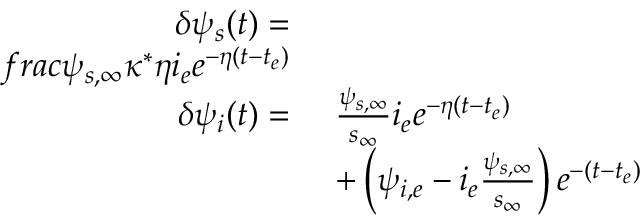<formula> <loc_0><loc_0><loc_500><loc_500>\begin{array} { r l } { \delta \psi _ { s } ( t ) = } \\ { f r a c { \psi _ { s , \infty } \kappa ^ { * } } { \eta } i _ { e } e ^ { - \eta ( t - t _ { e } ) } } \\ { \delta \psi _ { i } ( t ) = } & { \ \frac { \psi _ { s , \infty } } { s _ { \infty } } i _ { e } e ^ { - \eta ( t - t _ { e } ) } } \\ & { \ + \left ( \psi _ { i , e } - i _ { e } \frac { \psi _ { s , \infty } } { s _ { \infty } } \right ) e ^ { - ( t - t _ { e } ) } } \end{array}</formula> 